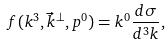<formula> <loc_0><loc_0><loc_500><loc_500>f ( k ^ { 3 } , \vec { k } ^ { \bot } , p ^ { 0 } ) = k ^ { 0 } \frac { d \sigma } { d ^ { 3 } k } ,</formula> 